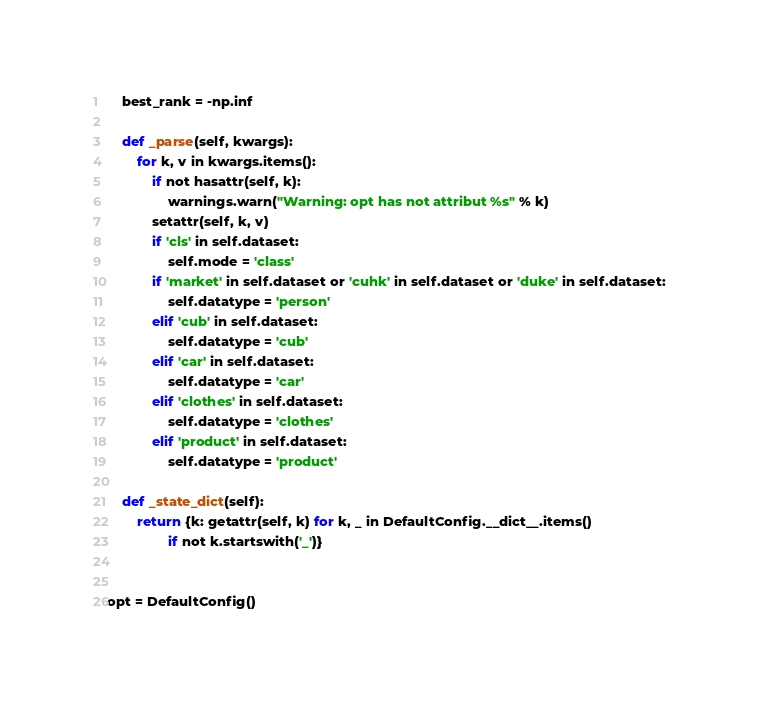<code> <loc_0><loc_0><loc_500><loc_500><_Python_>    best_rank = -np.inf

    def _parse(self, kwargs):
        for k, v in kwargs.items():
            if not hasattr(self, k):
                warnings.warn("Warning: opt has not attribut %s" % k)
            setattr(self, k, v)
            if 'cls' in self.dataset:
                self.mode = 'class'
            if 'market' in self.dataset or 'cuhk' in self.dataset or 'duke' in self.dataset:
                self.datatype = 'person'
            elif 'cub' in self.dataset:
                self.datatype = 'cub'
            elif 'car' in self.dataset:
                self.datatype = 'car'
            elif 'clothes' in self.dataset:
                self.datatype = 'clothes'
            elif 'product' in self.dataset:
                self.datatype = 'product'

    def _state_dict(self):
        return {k: getattr(self, k) for k, _ in DefaultConfig.__dict__.items()
                if not k.startswith('_')}


opt = DefaultConfig()
</code> 